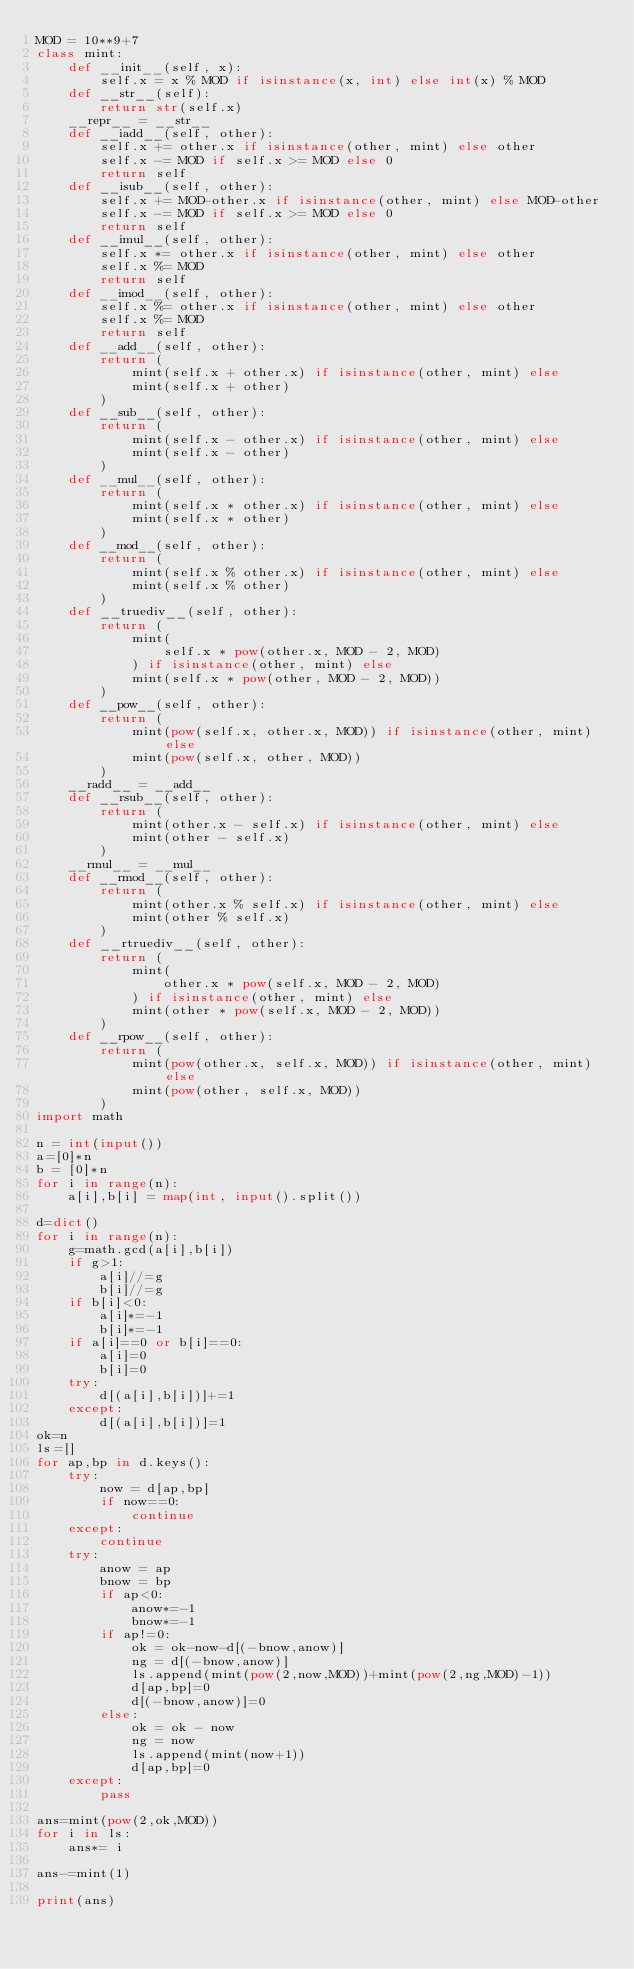<code> <loc_0><loc_0><loc_500><loc_500><_Python_>MOD = 10**9+7
class mint:
    def __init__(self, x):
        self.x = x % MOD if isinstance(x, int) else int(x) % MOD
    def __str__(self):
        return str(self.x)
    __repr__ = __str__
    def __iadd__(self, other):
        self.x += other.x if isinstance(other, mint) else other
        self.x -= MOD if self.x >= MOD else 0
        return self
    def __isub__(self, other):
        self.x += MOD-other.x if isinstance(other, mint) else MOD-other
        self.x -= MOD if self.x >= MOD else 0
        return self
    def __imul__(self, other):
        self.x *= other.x if isinstance(other, mint) else other
        self.x %= MOD
        return self
    def __imod__(self, other):
        self.x %= other.x if isinstance(other, mint) else other
        self.x %= MOD
        return self
    def __add__(self, other):
        return (
            mint(self.x + other.x) if isinstance(other, mint) else
            mint(self.x + other)
        )
    def __sub__(self, other):
        return (
            mint(self.x - other.x) if isinstance(other, mint) else
            mint(self.x - other)
        )
    def __mul__(self, other):
        return (
            mint(self.x * other.x) if isinstance(other, mint) else
            mint(self.x * other)
        )
    def __mod__(self, other):
        return (
            mint(self.x % other.x) if isinstance(other, mint) else
            mint(self.x % other)
        )
    def __truediv__(self, other):
        return (
            mint(
                self.x * pow(other.x, MOD - 2, MOD)
            ) if isinstance(other, mint) else
            mint(self.x * pow(other, MOD - 2, MOD))
        )
    def __pow__(self, other):
        return (
            mint(pow(self.x, other.x, MOD)) if isinstance(other, mint) else
            mint(pow(self.x, other, MOD))
        )
    __radd__ = __add__
    def __rsub__(self, other):
        return (
            mint(other.x - self.x) if isinstance(other, mint) else
            mint(other - self.x)
        )
    __rmul__ = __mul__
    def __rmod__(self, other):
        return (
            mint(other.x % self.x) if isinstance(other, mint) else
            mint(other % self.x)
        )
    def __rtruediv__(self, other):
        return (
            mint(
                other.x * pow(self.x, MOD - 2, MOD)
            ) if isinstance(other, mint) else
            mint(other * pow(self.x, MOD - 2, MOD))
        )
    def __rpow__(self, other):
        return (
            mint(pow(other.x, self.x, MOD)) if isinstance(other, mint) else
            mint(pow(other, self.x, MOD))
        )
import math

n = int(input())
a=[0]*n
b = [0]*n
for i in range(n):
    a[i],b[i] = map(int, input().split())

d=dict()
for i in range(n):
    g=math.gcd(a[i],b[i])
    if g>1:
        a[i]//=g
        b[i]//=g
    if b[i]<0:
        a[i]*=-1
        b[i]*=-1
    if a[i]==0 or b[i]==0:
        a[i]=0
        b[i]=0
    try:
        d[(a[i],b[i])]+=1
    except:
        d[(a[i],b[i])]=1
ok=n
ls=[]
for ap,bp in d.keys():
    try:
        now = d[ap,bp]
        if now==0:
            continue
    except:
        continue
    try:
        anow = ap
        bnow = bp
        if ap<0:
            anow*=-1
            bnow*=-1
        if ap!=0:
            ok = ok-now-d[(-bnow,anow)]
            ng = d[(-bnow,anow)]
            ls.append(mint(pow(2,now,MOD))+mint(pow(2,ng,MOD)-1))
            d[ap,bp]=0
            d[(-bnow,anow)]=0
        else:
            ok = ok - now
            ng = now
            ls.append(mint(now+1))
            d[ap,bp]=0
    except:
        pass

ans=mint(pow(2,ok,MOD))
for i in ls:
    ans*= i

ans-=mint(1)

print(ans)</code> 